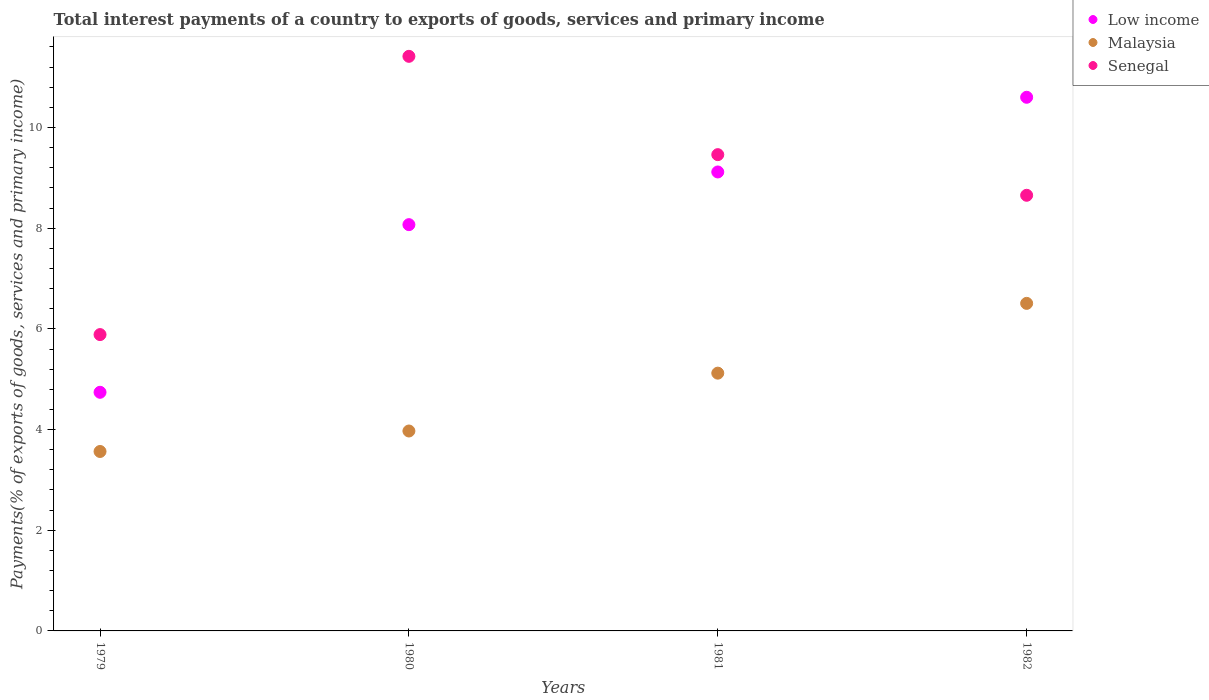Is the number of dotlines equal to the number of legend labels?
Offer a very short reply. Yes. What is the total interest payments in Malaysia in 1980?
Your answer should be very brief. 3.97. Across all years, what is the maximum total interest payments in Senegal?
Ensure brevity in your answer.  11.41. Across all years, what is the minimum total interest payments in Malaysia?
Provide a short and direct response. 3.56. In which year was the total interest payments in Low income minimum?
Make the answer very short. 1979. What is the total total interest payments in Malaysia in the graph?
Provide a succinct answer. 19.16. What is the difference between the total interest payments in Senegal in 1979 and that in 1981?
Provide a succinct answer. -3.57. What is the difference between the total interest payments in Low income in 1979 and the total interest payments in Malaysia in 1980?
Give a very brief answer. 0.77. What is the average total interest payments in Malaysia per year?
Give a very brief answer. 4.79. In the year 1981, what is the difference between the total interest payments in Malaysia and total interest payments in Low income?
Give a very brief answer. -4. In how many years, is the total interest payments in Low income greater than 2.4 %?
Your response must be concise. 4. What is the ratio of the total interest payments in Malaysia in 1980 to that in 1981?
Give a very brief answer. 0.78. Is the total interest payments in Low income in 1979 less than that in 1980?
Keep it short and to the point. Yes. Is the difference between the total interest payments in Malaysia in 1981 and 1982 greater than the difference between the total interest payments in Low income in 1981 and 1982?
Ensure brevity in your answer.  Yes. What is the difference between the highest and the second highest total interest payments in Senegal?
Offer a terse response. 1.95. What is the difference between the highest and the lowest total interest payments in Senegal?
Provide a short and direct response. 5.53. Is the sum of the total interest payments in Malaysia in 1981 and 1982 greater than the maximum total interest payments in Senegal across all years?
Give a very brief answer. Yes. Is it the case that in every year, the sum of the total interest payments in Senegal and total interest payments in Low income  is greater than the total interest payments in Malaysia?
Your response must be concise. Yes. Does the total interest payments in Low income monotonically increase over the years?
Ensure brevity in your answer.  Yes. Is the total interest payments in Low income strictly less than the total interest payments in Malaysia over the years?
Make the answer very short. No. How many dotlines are there?
Offer a very short reply. 3. What is the difference between two consecutive major ticks on the Y-axis?
Keep it short and to the point. 2. Are the values on the major ticks of Y-axis written in scientific E-notation?
Your answer should be compact. No. Does the graph contain grids?
Keep it short and to the point. No. What is the title of the graph?
Your response must be concise. Total interest payments of a country to exports of goods, services and primary income. What is the label or title of the X-axis?
Make the answer very short. Years. What is the label or title of the Y-axis?
Your answer should be compact. Payments(% of exports of goods, services and primary income). What is the Payments(% of exports of goods, services and primary income) of Low income in 1979?
Give a very brief answer. 4.74. What is the Payments(% of exports of goods, services and primary income) of Malaysia in 1979?
Your answer should be compact. 3.56. What is the Payments(% of exports of goods, services and primary income) in Senegal in 1979?
Make the answer very short. 5.89. What is the Payments(% of exports of goods, services and primary income) in Low income in 1980?
Your answer should be very brief. 8.07. What is the Payments(% of exports of goods, services and primary income) of Malaysia in 1980?
Keep it short and to the point. 3.97. What is the Payments(% of exports of goods, services and primary income) of Senegal in 1980?
Your response must be concise. 11.41. What is the Payments(% of exports of goods, services and primary income) in Low income in 1981?
Provide a succinct answer. 9.12. What is the Payments(% of exports of goods, services and primary income) of Malaysia in 1981?
Ensure brevity in your answer.  5.12. What is the Payments(% of exports of goods, services and primary income) of Senegal in 1981?
Provide a succinct answer. 9.46. What is the Payments(% of exports of goods, services and primary income) of Low income in 1982?
Ensure brevity in your answer.  10.6. What is the Payments(% of exports of goods, services and primary income) in Malaysia in 1982?
Provide a short and direct response. 6.51. What is the Payments(% of exports of goods, services and primary income) of Senegal in 1982?
Offer a terse response. 8.65. Across all years, what is the maximum Payments(% of exports of goods, services and primary income) of Low income?
Make the answer very short. 10.6. Across all years, what is the maximum Payments(% of exports of goods, services and primary income) of Malaysia?
Keep it short and to the point. 6.51. Across all years, what is the maximum Payments(% of exports of goods, services and primary income) of Senegal?
Keep it short and to the point. 11.41. Across all years, what is the minimum Payments(% of exports of goods, services and primary income) of Low income?
Keep it short and to the point. 4.74. Across all years, what is the minimum Payments(% of exports of goods, services and primary income) in Malaysia?
Keep it short and to the point. 3.56. Across all years, what is the minimum Payments(% of exports of goods, services and primary income) in Senegal?
Ensure brevity in your answer.  5.89. What is the total Payments(% of exports of goods, services and primary income) of Low income in the graph?
Offer a very short reply. 32.53. What is the total Payments(% of exports of goods, services and primary income) in Malaysia in the graph?
Your answer should be very brief. 19.16. What is the total Payments(% of exports of goods, services and primary income) of Senegal in the graph?
Your answer should be compact. 35.42. What is the difference between the Payments(% of exports of goods, services and primary income) in Low income in 1979 and that in 1980?
Offer a very short reply. -3.33. What is the difference between the Payments(% of exports of goods, services and primary income) in Malaysia in 1979 and that in 1980?
Provide a succinct answer. -0.41. What is the difference between the Payments(% of exports of goods, services and primary income) in Senegal in 1979 and that in 1980?
Keep it short and to the point. -5.53. What is the difference between the Payments(% of exports of goods, services and primary income) in Low income in 1979 and that in 1981?
Your answer should be compact. -4.38. What is the difference between the Payments(% of exports of goods, services and primary income) in Malaysia in 1979 and that in 1981?
Provide a succinct answer. -1.56. What is the difference between the Payments(% of exports of goods, services and primary income) of Senegal in 1979 and that in 1981?
Make the answer very short. -3.57. What is the difference between the Payments(% of exports of goods, services and primary income) in Low income in 1979 and that in 1982?
Offer a terse response. -5.86. What is the difference between the Payments(% of exports of goods, services and primary income) of Malaysia in 1979 and that in 1982?
Provide a short and direct response. -2.94. What is the difference between the Payments(% of exports of goods, services and primary income) of Senegal in 1979 and that in 1982?
Offer a terse response. -2.77. What is the difference between the Payments(% of exports of goods, services and primary income) in Low income in 1980 and that in 1981?
Provide a short and direct response. -1.05. What is the difference between the Payments(% of exports of goods, services and primary income) in Malaysia in 1980 and that in 1981?
Your answer should be very brief. -1.15. What is the difference between the Payments(% of exports of goods, services and primary income) in Senegal in 1980 and that in 1981?
Your answer should be very brief. 1.95. What is the difference between the Payments(% of exports of goods, services and primary income) in Low income in 1980 and that in 1982?
Offer a very short reply. -2.53. What is the difference between the Payments(% of exports of goods, services and primary income) of Malaysia in 1980 and that in 1982?
Your answer should be compact. -2.54. What is the difference between the Payments(% of exports of goods, services and primary income) of Senegal in 1980 and that in 1982?
Your answer should be compact. 2.76. What is the difference between the Payments(% of exports of goods, services and primary income) of Low income in 1981 and that in 1982?
Make the answer very short. -1.48. What is the difference between the Payments(% of exports of goods, services and primary income) of Malaysia in 1981 and that in 1982?
Provide a short and direct response. -1.39. What is the difference between the Payments(% of exports of goods, services and primary income) of Senegal in 1981 and that in 1982?
Offer a terse response. 0.81. What is the difference between the Payments(% of exports of goods, services and primary income) of Low income in 1979 and the Payments(% of exports of goods, services and primary income) of Malaysia in 1980?
Offer a very short reply. 0.77. What is the difference between the Payments(% of exports of goods, services and primary income) of Low income in 1979 and the Payments(% of exports of goods, services and primary income) of Senegal in 1980?
Ensure brevity in your answer.  -6.67. What is the difference between the Payments(% of exports of goods, services and primary income) of Malaysia in 1979 and the Payments(% of exports of goods, services and primary income) of Senegal in 1980?
Make the answer very short. -7.85. What is the difference between the Payments(% of exports of goods, services and primary income) in Low income in 1979 and the Payments(% of exports of goods, services and primary income) in Malaysia in 1981?
Your answer should be compact. -0.38. What is the difference between the Payments(% of exports of goods, services and primary income) in Low income in 1979 and the Payments(% of exports of goods, services and primary income) in Senegal in 1981?
Keep it short and to the point. -4.72. What is the difference between the Payments(% of exports of goods, services and primary income) of Malaysia in 1979 and the Payments(% of exports of goods, services and primary income) of Senegal in 1981?
Provide a short and direct response. -5.9. What is the difference between the Payments(% of exports of goods, services and primary income) of Low income in 1979 and the Payments(% of exports of goods, services and primary income) of Malaysia in 1982?
Make the answer very short. -1.77. What is the difference between the Payments(% of exports of goods, services and primary income) in Low income in 1979 and the Payments(% of exports of goods, services and primary income) in Senegal in 1982?
Make the answer very short. -3.91. What is the difference between the Payments(% of exports of goods, services and primary income) of Malaysia in 1979 and the Payments(% of exports of goods, services and primary income) of Senegal in 1982?
Your answer should be compact. -5.09. What is the difference between the Payments(% of exports of goods, services and primary income) of Low income in 1980 and the Payments(% of exports of goods, services and primary income) of Malaysia in 1981?
Provide a short and direct response. 2.95. What is the difference between the Payments(% of exports of goods, services and primary income) of Low income in 1980 and the Payments(% of exports of goods, services and primary income) of Senegal in 1981?
Offer a very short reply. -1.39. What is the difference between the Payments(% of exports of goods, services and primary income) of Malaysia in 1980 and the Payments(% of exports of goods, services and primary income) of Senegal in 1981?
Give a very brief answer. -5.49. What is the difference between the Payments(% of exports of goods, services and primary income) of Low income in 1980 and the Payments(% of exports of goods, services and primary income) of Malaysia in 1982?
Provide a short and direct response. 1.56. What is the difference between the Payments(% of exports of goods, services and primary income) in Low income in 1980 and the Payments(% of exports of goods, services and primary income) in Senegal in 1982?
Make the answer very short. -0.58. What is the difference between the Payments(% of exports of goods, services and primary income) in Malaysia in 1980 and the Payments(% of exports of goods, services and primary income) in Senegal in 1982?
Provide a succinct answer. -4.68. What is the difference between the Payments(% of exports of goods, services and primary income) in Low income in 1981 and the Payments(% of exports of goods, services and primary income) in Malaysia in 1982?
Ensure brevity in your answer.  2.61. What is the difference between the Payments(% of exports of goods, services and primary income) in Low income in 1981 and the Payments(% of exports of goods, services and primary income) in Senegal in 1982?
Your response must be concise. 0.46. What is the difference between the Payments(% of exports of goods, services and primary income) in Malaysia in 1981 and the Payments(% of exports of goods, services and primary income) in Senegal in 1982?
Keep it short and to the point. -3.53. What is the average Payments(% of exports of goods, services and primary income) in Low income per year?
Offer a terse response. 8.13. What is the average Payments(% of exports of goods, services and primary income) in Malaysia per year?
Provide a short and direct response. 4.79. What is the average Payments(% of exports of goods, services and primary income) in Senegal per year?
Keep it short and to the point. 8.85. In the year 1979, what is the difference between the Payments(% of exports of goods, services and primary income) in Low income and Payments(% of exports of goods, services and primary income) in Malaysia?
Your response must be concise. 1.18. In the year 1979, what is the difference between the Payments(% of exports of goods, services and primary income) of Low income and Payments(% of exports of goods, services and primary income) of Senegal?
Your response must be concise. -1.15. In the year 1979, what is the difference between the Payments(% of exports of goods, services and primary income) of Malaysia and Payments(% of exports of goods, services and primary income) of Senegal?
Give a very brief answer. -2.32. In the year 1980, what is the difference between the Payments(% of exports of goods, services and primary income) in Low income and Payments(% of exports of goods, services and primary income) in Malaysia?
Provide a succinct answer. 4.1. In the year 1980, what is the difference between the Payments(% of exports of goods, services and primary income) in Low income and Payments(% of exports of goods, services and primary income) in Senegal?
Your response must be concise. -3.34. In the year 1980, what is the difference between the Payments(% of exports of goods, services and primary income) of Malaysia and Payments(% of exports of goods, services and primary income) of Senegal?
Offer a very short reply. -7.44. In the year 1981, what is the difference between the Payments(% of exports of goods, services and primary income) of Low income and Payments(% of exports of goods, services and primary income) of Malaysia?
Make the answer very short. 4. In the year 1981, what is the difference between the Payments(% of exports of goods, services and primary income) in Low income and Payments(% of exports of goods, services and primary income) in Senegal?
Your response must be concise. -0.34. In the year 1981, what is the difference between the Payments(% of exports of goods, services and primary income) in Malaysia and Payments(% of exports of goods, services and primary income) in Senegal?
Ensure brevity in your answer.  -4.34. In the year 1982, what is the difference between the Payments(% of exports of goods, services and primary income) in Low income and Payments(% of exports of goods, services and primary income) in Malaysia?
Provide a short and direct response. 4.09. In the year 1982, what is the difference between the Payments(% of exports of goods, services and primary income) of Low income and Payments(% of exports of goods, services and primary income) of Senegal?
Offer a very short reply. 1.95. In the year 1982, what is the difference between the Payments(% of exports of goods, services and primary income) of Malaysia and Payments(% of exports of goods, services and primary income) of Senegal?
Your answer should be compact. -2.15. What is the ratio of the Payments(% of exports of goods, services and primary income) of Low income in 1979 to that in 1980?
Provide a short and direct response. 0.59. What is the ratio of the Payments(% of exports of goods, services and primary income) in Malaysia in 1979 to that in 1980?
Provide a succinct answer. 0.9. What is the ratio of the Payments(% of exports of goods, services and primary income) in Senegal in 1979 to that in 1980?
Give a very brief answer. 0.52. What is the ratio of the Payments(% of exports of goods, services and primary income) of Low income in 1979 to that in 1981?
Your answer should be compact. 0.52. What is the ratio of the Payments(% of exports of goods, services and primary income) of Malaysia in 1979 to that in 1981?
Offer a terse response. 0.7. What is the ratio of the Payments(% of exports of goods, services and primary income) in Senegal in 1979 to that in 1981?
Your response must be concise. 0.62. What is the ratio of the Payments(% of exports of goods, services and primary income) in Low income in 1979 to that in 1982?
Keep it short and to the point. 0.45. What is the ratio of the Payments(% of exports of goods, services and primary income) in Malaysia in 1979 to that in 1982?
Offer a terse response. 0.55. What is the ratio of the Payments(% of exports of goods, services and primary income) in Senegal in 1979 to that in 1982?
Provide a succinct answer. 0.68. What is the ratio of the Payments(% of exports of goods, services and primary income) in Low income in 1980 to that in 1981?
Make the answer very short. 0.89. What is the ratio of the Payments(% of exports of goods, services and primary income) of Malaysia in 1980 to that in 1981?
Provide a succinct answer. 0.78. What is the ratio of the Payments(% of exports of goods, services and primary income) in Senegal in 1980 to that in 1981?
Give a very brief answer. 1.21. What is the ratio of the Payments(% of exports of goods, services and primary income) in Low income in 1980 to that in 1982?
Keep it short and to the point. 0.76. What is the ratio of the Payments(% of exports of goods, services and primary income) in Malaysia in 1980 to that in 1982?
Give a very brief answer. 0.61. What is the ratio of the Payments(% of exports of goods, services and primary income) in Senegal in 1980 to that in 1982?
Offer a very short reply. 1.32. What is the ratio of the Payments(% of exports of goods, services and primary income) in Low income in 1981 to that in 1982?
Your answer should be compact. 0.86. What is the ratio of the Payments(% of exports of goods, services and primary income) of Malaysia in 1981 to that in 1982?
Your answer should be compact. 0.79. What is the ratio of the Payments(% of exports of goods, services and primary income) of Senegal in 1981 to that in 1982?
Your answer should be compact. 1.09. What is the difference between the highest and the second highest Payments(% of exports of goods, services and primary income) of Low income?
Offer a very short reply. 1.48. What is the difference between the highest and the second highest Payments(% of exports of goods, services and primary income) of Malaysia?
Give a very brief answer. 1.39. What is the difference between the highest and the second highest Payments(% of exports of goods, services and primary income) of Senegal?
Ensure brevity in your answer.  1.95. What is the difference between the highest and the lowest Payments(% of exports of goods, services and primary income) in Low income?
Ensure brevity in your answer.  5.86. What is the difference between the highest and the lowest Payments(% of exports of goods, services and primary income) of Malaysia?
Offer a terse response. 2.94. What is the difference between the highest and the lowest Payments(% of exports of goods, services and primary income) of Senegal?
Your response must be concise. 5.53. 